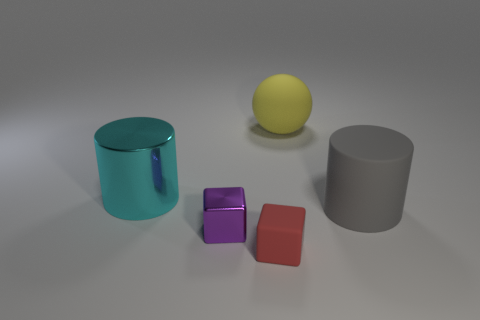Is the color of the tiny object left of the red rubber object the same as the large rubber cylinder?
Keep it short and to the point. No. What number of blocks are large yellow matte objects or purple things?
Your answer should be very brief. 1. What shape is the thing that is right of the yellow matte object?
Your answer should be compact. Cylinder. The matte object in front of the big object on the right side of the big object that is behind the large cyan metal cylinder is what color?
Make the answer very short. Red. Is the large yellow ball made of the same material as the small purple block?
Keep it short and to the point. No. What number of red objects are small shiny blocks or large metallic balls?
Offer a terse response. 0. What number of large gray cylinders are on the left side of the big metallic thing?
Your answer should be compact. 0. Are there more tiny red matte things than cylinders?
Ensure brevity in your answer.  No. There is a thing that is on the left side of the metallic object that is in front of the big gray object; what shape is it?
Provide a succinct answer. Cylinder. Is the small matte cube the same color as the rubber cylinder?
Your response must be concise. No. 